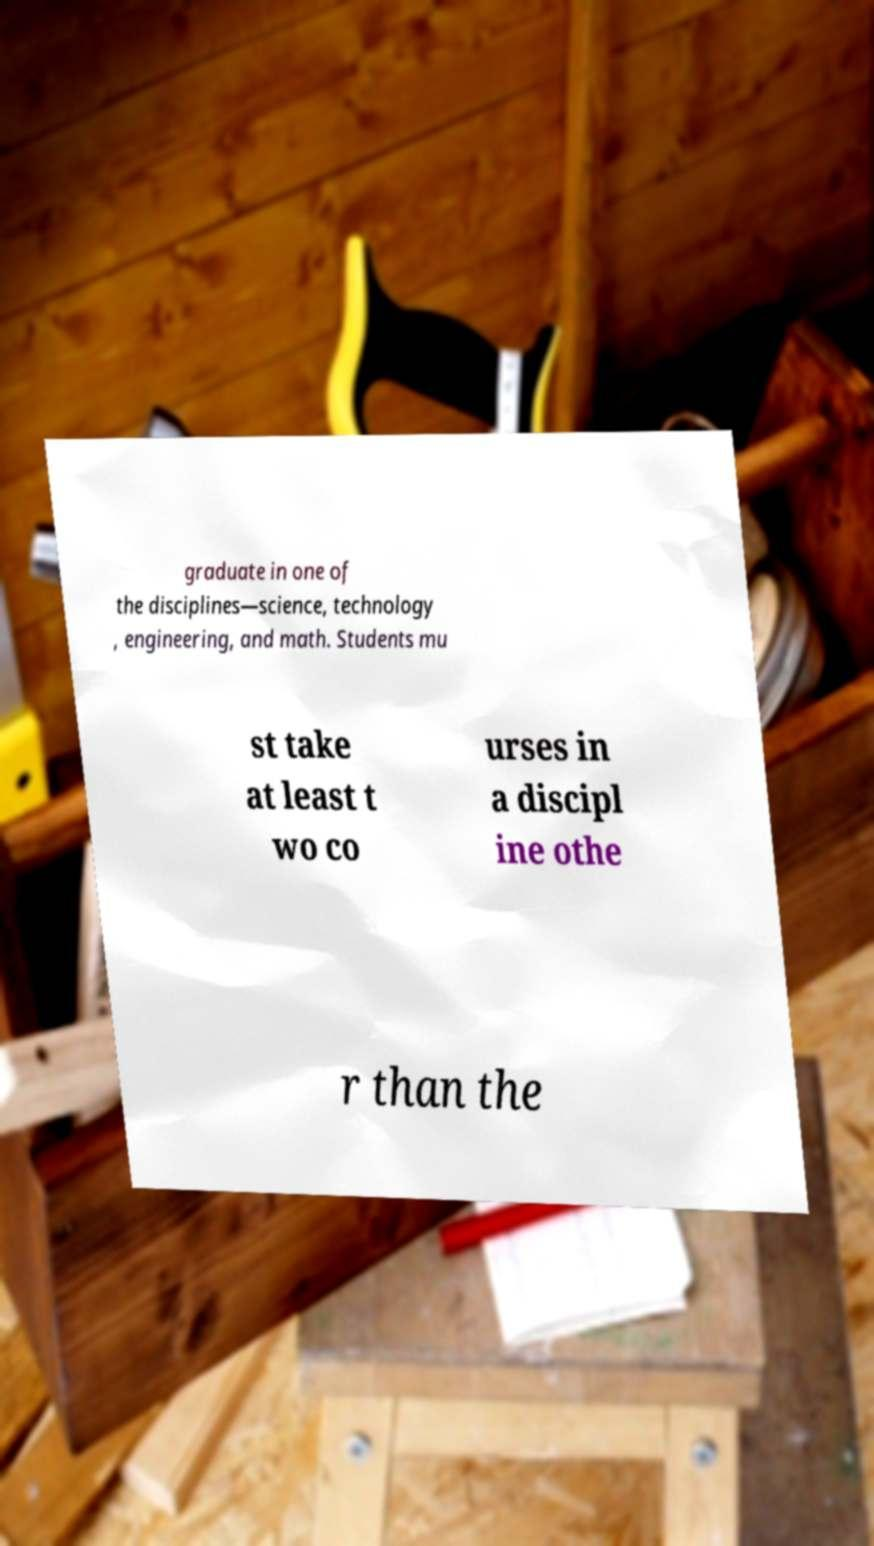There's text embedded in this image that I need extracted. Can you transcribe it verbatim? graduate in one of the disciplines—science, technology , engineering, and math. Students mu st take at least t wo co urses in a discipl ine othe r than the 